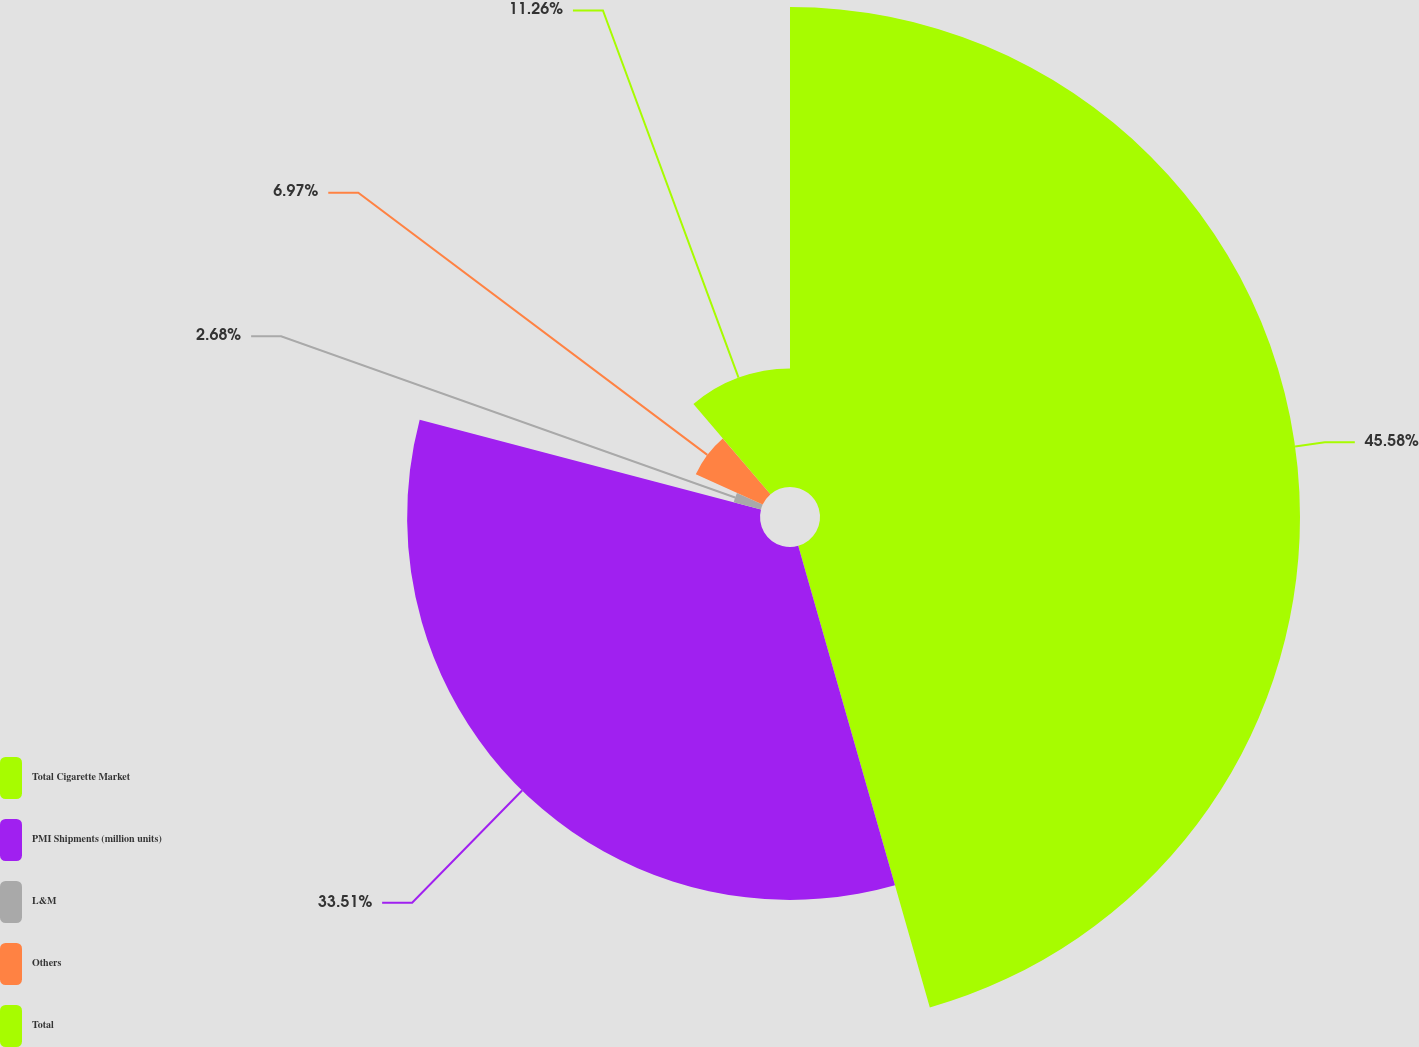<chart> <loc_0><loc_0><loc_500><loc_500><pie_chart><fcel>Total Cigarette Market<fcel>PMI Shipments (million units)<fcel>L&M<fcel>Others<fcel>Total<nl><fcel>45.58%<fcel>33.51%<fcel>2.68%<fcel>6.97%<fcel>11.26%<nl></chart> 